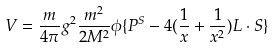<formula> <loc_0><loc_0><loc_500><loc_500>V = \frac { m } { 4 \pi } g ^ { 2 } \frac { m ^ { 2 } } { 2 M ^ { 2 } } \phi \{ P ^ { S } - 4 ( \frac { 1 } { x } + \frac { 1 } { x ^ { 2 } } ) { L } \cdot { S } \}</formula> 